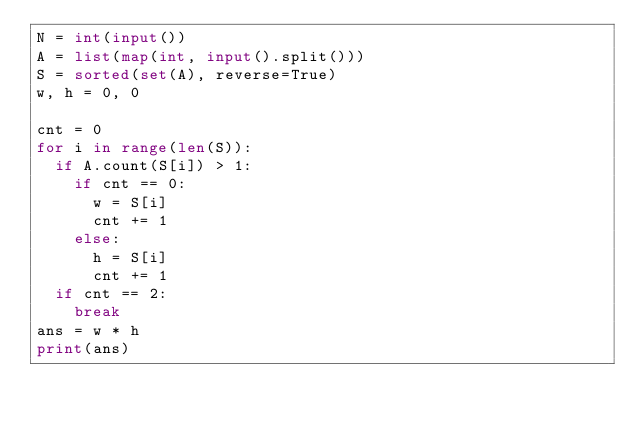<code> <loc_0><loc_0><loc_500><loc_500><_Python_>N = int(input())
A = list(map(int, input().split()))
S = sorted(set(A), reverse=True)
w, h = 0, 0

cnt = 0
for i in range(len(S)):
  if A.count(S[i]) > 1:
    if cnt == 0:
      w = S[i]
      cnt += 1
    else:
      h = S[i]
      cnt += 1
  if cnt == 2:
    break
ans = w * h
print(ans)</code> 